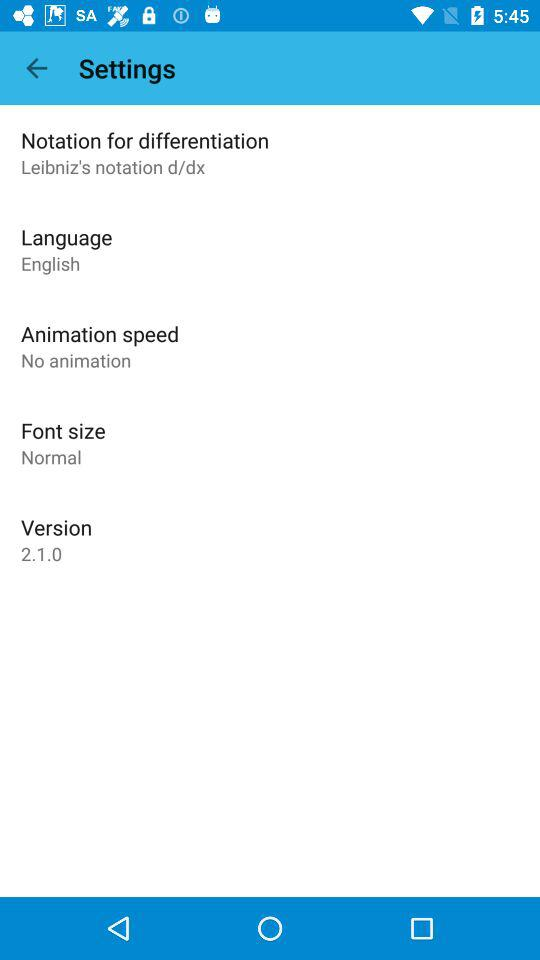What's the "Notation for differentiation"? The "Notation for differentiation" is "Leibniz's notation d/dx". 